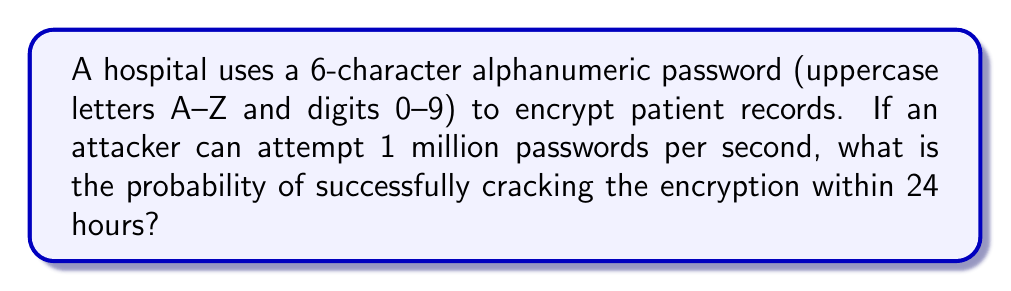Show me your answer to this math problem. Let's approach this step-by-step:

1. Calculate the total number of possible passwords:
   - Characters available: 26 uppercase letters + 10 digits = 36 characters
   - Password length: 6 characters
   - Total possible combinations: $36^6 = 2,176,782,336$

2. Calculate the number of attempts possible in 24 hours:
   - Attempts per second: 1,000,000
   - Seconds in 24 hours: $24 \times 60 \times 60 = 86,400$
   - Total attempts in 24 hours: $1,000,000 \times 86,400 = 86,400,000,000$

3. Calculate the probability of success:
   - Probability = (Number of favorable outcomes) / (Total number of possible outcomes)
   - In this case: (Number of attempts possible) / (Total number of possible passwords)
   - $P(\text{success}) = \frac{86,400,000,000}{2,176,782,336} \approx 39.69$

4. Since the probability is greater than 1, it means the attacker can try all possible combinations within 24 hours.

Therefore, the probability of successfully cracking the encryption within 24 hours is 1 (or 100%).
Answer: 1 